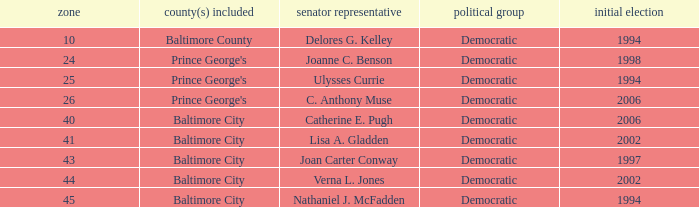Who was firest elected in 2002 in a district larger than 41? Verna L. Jones. 